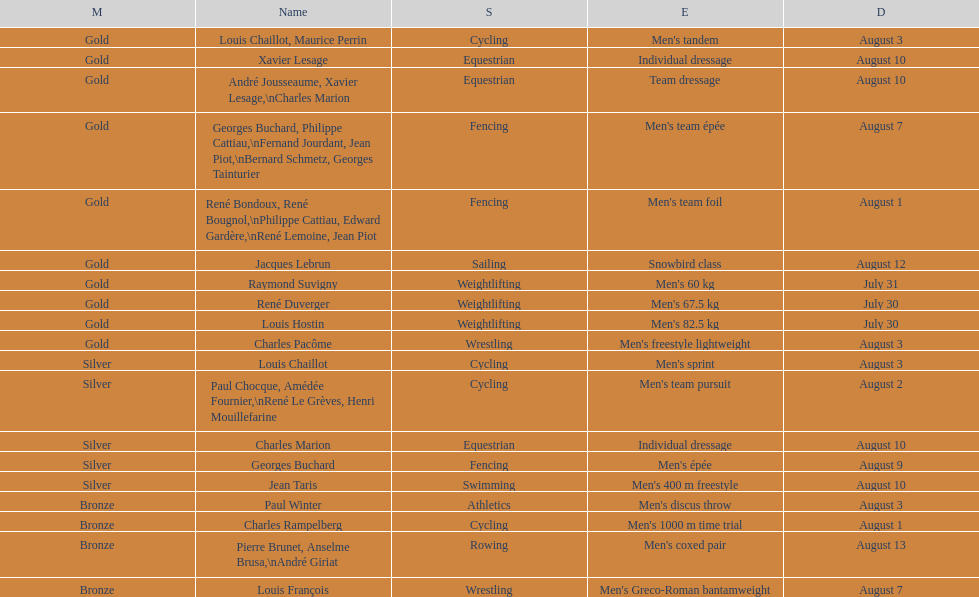How many cumulative gold medals have been earned by weightlifting? 3. 